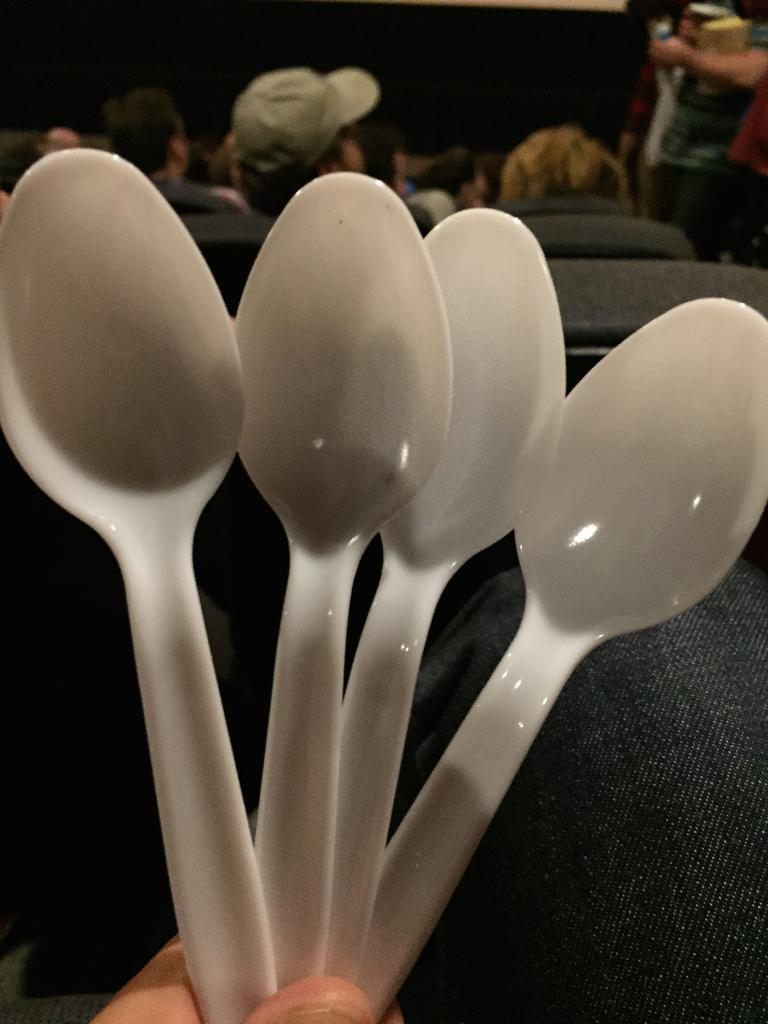What color are the spoons in the image? The spoons in the image are white-colored. Can you describe the people in the background of the image? There are people sitting on chairs in the background of the image. What type of control does the minister have over the copper in the image? There is no minister or copper present in the image. 